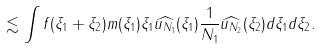<formula> <loc_0><loc_0><loc_500><loc_500>\lesssim \int f ( \xi _ { 1 } + \xi _ { 2 } ) m ( \xi _ { 1 } ) \xi _ { 1 } \widehat { u _ { N _ { 1 } } } ( \xi _ { 1 } ) \frac { 1 } { N _ { 1 } } \widehat { u _ { N _ { 2 } } } ( \xi _ { 2 } ) d \xi _ { 1 } d \xi _ { 2 } .</formula> 